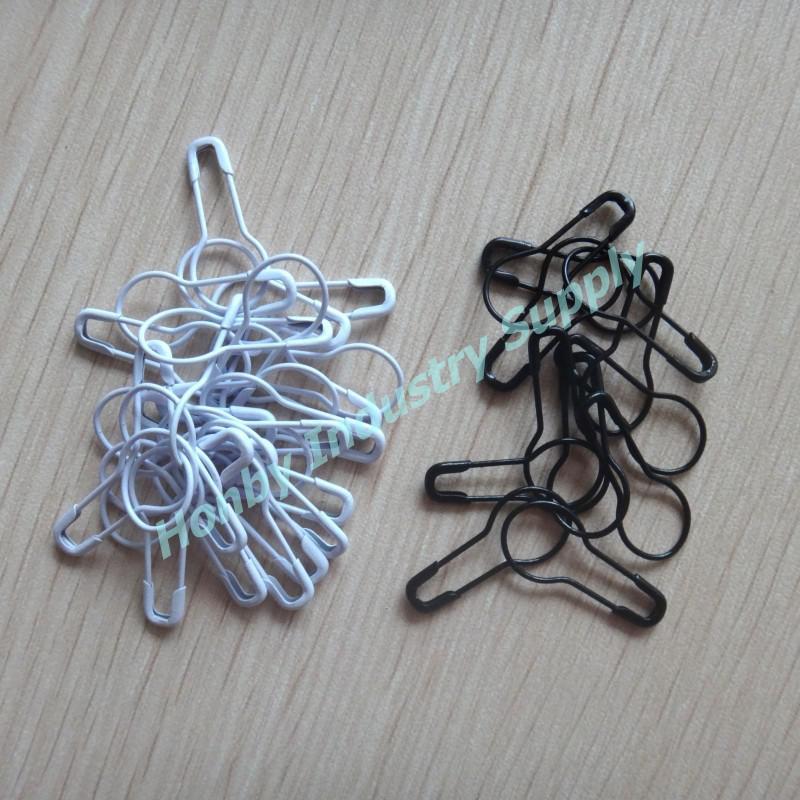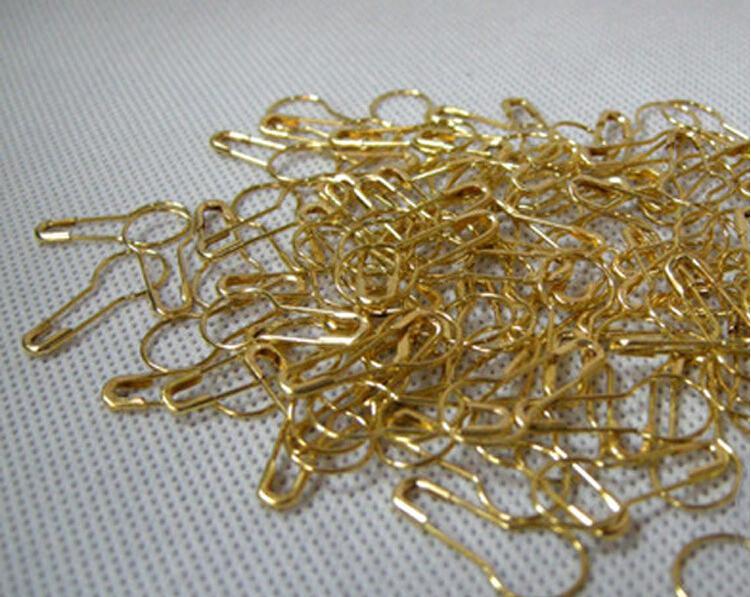The first image is the image on the left, the second image is the image on the right. Examine the images to the left and right. Is the description "An image shows only a pile of gold pins that are pear-shaped." accurate? Answer yes or no. Yes. 